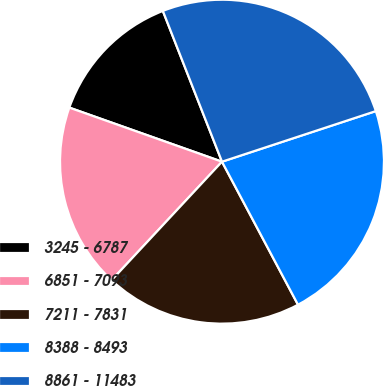Convert chart. <chart><loc_0><loc_0><loc_500><loc_500><pie_chart><fcel>3245 - 6787<fcel>6851 - 7093<fcel>7211 - 7831<fcel>8388 - 8493<fcel>8861 - 11483<nl><fcel>13.63%<fcel>18.48%<fcel>19.71%<fcel>22.28%<fcel>25.89%<nl></chart> 